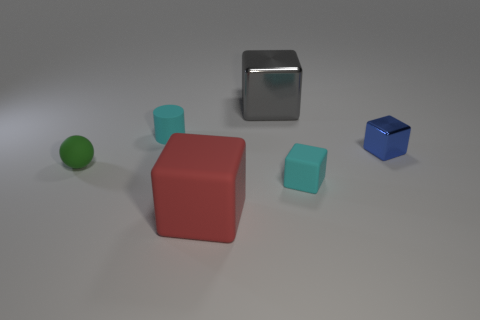Add 2 large purple rubber objects. How many objects exist? 8 Subtract all cylinders. How many objects are left? 5 Add 4 small brown rubber balls. How many small brown rubber balls exist? 4 Subtract 0 blue cylinders. How many objects are left? 6 Subtract all small metallic objects. Subtract all gray metal cubes. How many objects are left? 4 Add 3 big metallic blocks. How many big metallic blocks are left? 4 